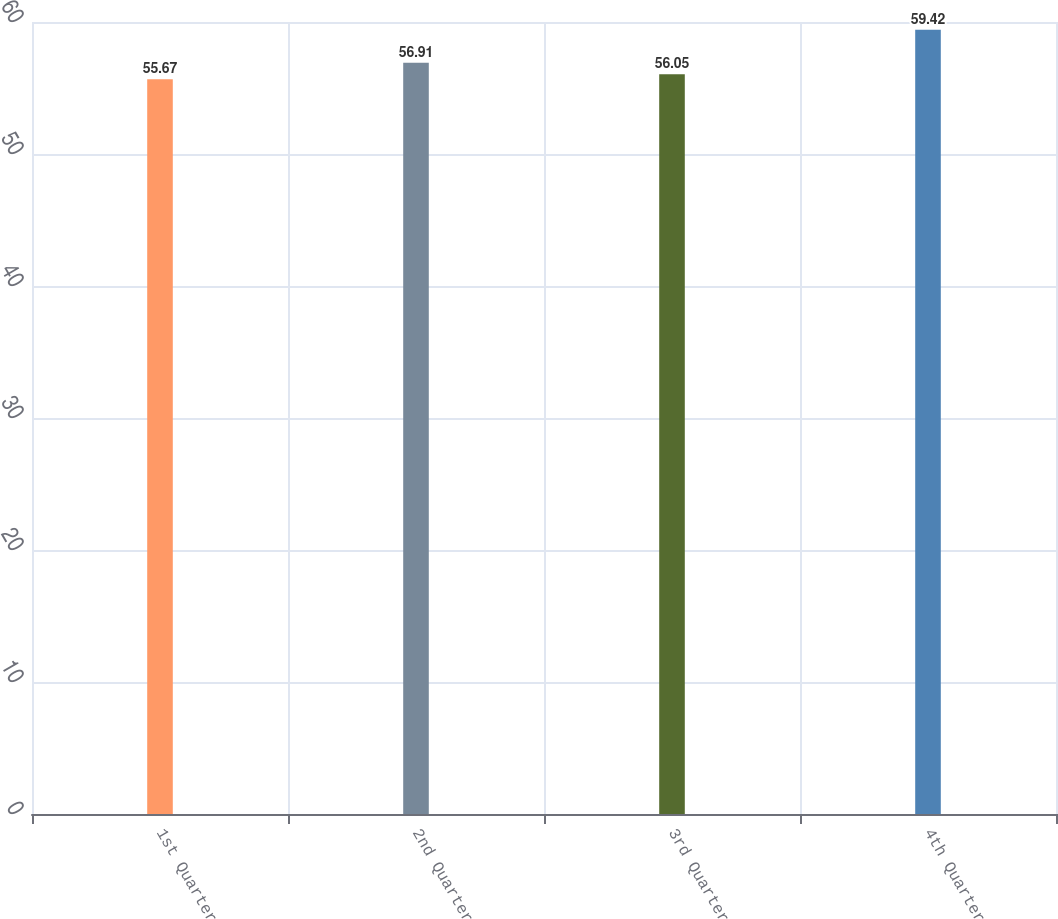<chart> <loc_0><loc_0><loc_500><loc_500><bar_chart><fcel>1st Quarter<fcel>2nd Quarter<fcel>3rd Quarter<fcel>4th Quarter<nl><fcel>55.67<fcel>56.91<fcel>56.05<fcel>59.42<nl></chart> 